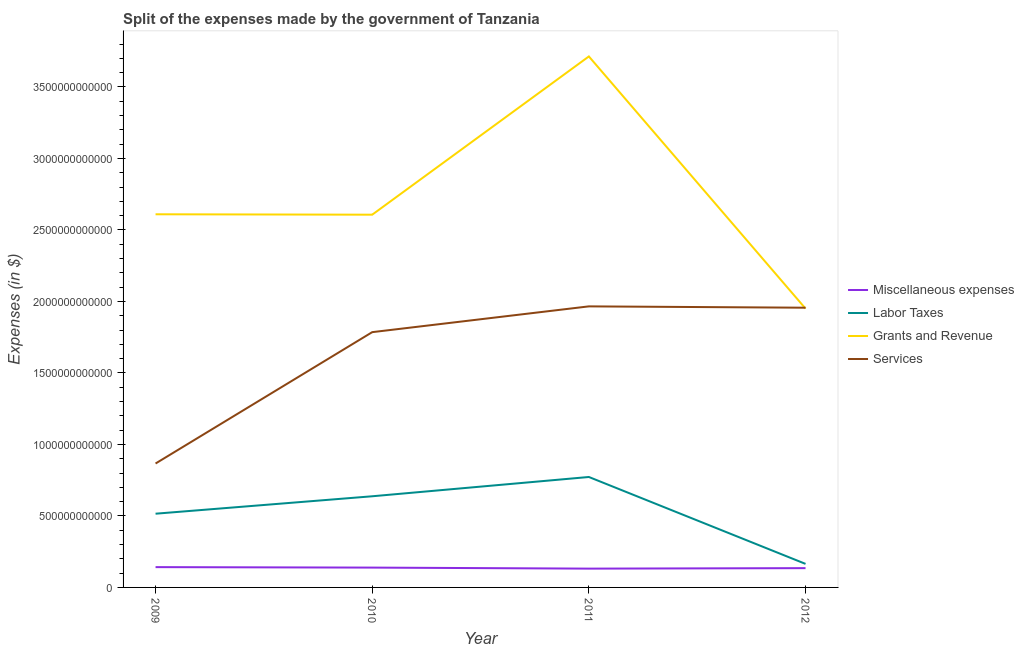How many different coloured lines are there?
Your answer should be very brief. 4. Is the number of lines equal to the number of legend labels?
Make the answer very short. Yes. What is the amount spent on services in 2010?
Give a very brief answer. 1.79e+12. Across all years, what is the maximum amount spent on miscellaneous expenses?
Make the answer very short. 1.42e+11. Across all years, what is the minimum amount spent on miscellaneous expenses?
Offer a very short reply. 1.31e+11. In which year was the amount spent on services maximum?
Provide a short and direct response. 2011. What is the total amount spent on grants and revenue in the graph?
Ensure brevity in your answer.  1.09e+13. What is the difference between the amount spent on labor taxes in 2009 and that in 2010?
Your response must be concise. -1.22e+11. What is the difference between the amount spent on grants and revenue in 2011 and the amount spent on services in 2010?
Offer a terse response. 1.93e+12. What is the average amount spent on services per year?
Provide a succinct answer. 1.64e+12. In the year 2012, what is the difference between the amount spent on grants and revenue and amount spent on labor taxes?
Provide a succinct answer. 1.79e+12. What is the ratio of the amount spent on services in 2009 to that in 2012?
Provide a short and direct response. 0.44. Is the difference between the amount spent on services in 2009 and 2011 greater than the difference between the amount spent on labor taxes in 2009 and 2011?
Your answer should be compact. No. What is the difference between the highest and the second highest amount spent on miscellaneous expenses?
Give a very brief answer. 3.24e+09. What is the difference between the highest and the lowest amount spent on grants and revenue?
Your response must be concise. 1.76e+12. In how many years, is the amount spent on services greater than the average amount spent on services taken over all years?
Your response must be concise. 3. Is it the case that in every year, the sum of the amount spent on services and amount spent on labor taxes is greater than the sum of amount spent on grants and revenue and amount spent on miscellaneous expenses?
Your answer should be very brief. Yes. Is the amount spent on miscellaneous expenses strictly greater than the amount spent on labor taxes over the years?
Ensure brevity in your answer.  No. How many lines are there?
Give a very brief answer. 4. How many years are there in the graph?
Provide a succinct answer. 4. What is the difference between two consecutive major ticks on the Y-axis?
Provide a succinct answer. 5.00e+11. Are the values on the major ticks of Y-axis written in scientific E-notation?
Your response must be concise. No. Does the graph contain any zero values?
Provide a succinct answer. No. Does the graph contain grids?
Offer a terse response. No. Where does the legend appear in the graph?
Ensure brevity in your answer.  Center right. How are the legend labels stacked?
Offer a terse response. Vertical. What is the title of the graph?
Ensure brevity in your answer.  Split of the expenses made by the government of Tanzania. What is the label or title of the Y-axis?
Your response must be concise. Expenses (in $). What is the Expenses (in $) of Miscellaneous expenses in 2009?
Give a very brief answer. 1.42e+11. What is the Expenses (in $) in Labor Taxes in 2009?
Your answer should be very brief. 5.16e+11. What is the Expenses (in $) in Grants and Revenue in 2009?
Offer a very short reply. 2.61e+12. What is the Expenses (in $) of Services in 2009?
Keep it short and to the point. 8.67e+11. What is the Expenses (in $) of Miscellaneous expenses in 2010?
Your answer should be compact. 1.39e+11. What is the Expenses (in $) in Labor Taxes in 2010?
Give a very brief answer. 6.38e+11. What is the Expenses (in $) in Grants and Revenue in 2010?
Ensure brevity in your answer.  2.61e+12. What is the Expenses (in $) in Services in 2010?
Your answer should be very brief. 1.79e+12. What is the Expenses (in $) in Miscellaneous expenses in 2011?
Offer a very short reply. 1.31e+11. What is the Expenses (in $) in Labor Taxes in 2011?
Your answer should be very brief. 7.72e+11. What is the Expenses (in $) of Grants and Revenue in 2011?
Your answer should be very brief. 3.71e+12. What is the Expenses (in $) in Services in 2011?
Offer a terse response. 1.97e+12. What is the Expenses (in $) in Miscellaneous expenses in 2012?
Offer a very short reply. 1.35e+11. What is the Expenses (in $) of Labor Taxes in 2012?
Keep it short and to the point. 1.65e+11. What is the Expenses (in $) of Grants and Revenue in 2012?
Your answer should be very brief. 1.95e+12. What is the Expenses (in $) in Services in 2012?
Keep it short and to the point. 1.96e+12. Across all years, what is the maximum Expenses (in $) in Miscellaneous expenses?
Give a very brief answer. 1.42e+11. Across all years, what is the maximum Expenses (in $) in Labor Taxes?
Keep it short and to the point. 7.72e+11. Across all years, what is the maximum Expenses (in $) of Grants and Revenue?
Provide a short and direct response. 3.71e+12. Across all years, what is the maximum Expenses (in $) of Services?
Your answer should be compact. 1.97e+12. Across all years, what is the minimum Expenses (in $) of Miscellaneous expenses?
Your response must be concise. 1.31e+11. Across all years, what is the minimum Expenses (in $) of Labor Taxes?
Offer a very short reply. 1.65e+11. Across all years, what is the minimum Expenses (in $) of Grants and Revenue?
Provide a succinct answer. 1.95e+12. Across all years, what is the minimum Expenses (in $) in Services?
Provide a short and direct response. 8.67e+11. What is the total Expenses (in $) of Miscellaneous expenses in the graph?
Your answer should be compact. 5.47e+11. What is the total Expenses (in $) of Labor Taxes in the graph?
Ensure brevity in your answer.  2.09e+12. What is the total Expenses (in $) in Grants and Revenue in the graph?
Offer a very short reply. 1.09e+13. What is the total Expenses (in $) of Services in the graph?
Give a very brief answer. 6.57e+12. What is the difference between the Expenses (in $) of Miscellaneous expenses in 2009 and that in 2010?
Provide a short and direct response. 3.24e+09. What is the difference between the Expenses (in $) of Labor Taxes in 2009 and that in 2010?
Your answer should be very brief. -1.22e+11. What is the difference between the Expenses (in $) in Grants and Revenue in 2009 and that in 2010?
Ensure brevity in your answer.  2.83e+09. What is the difference between the Expenses (in $) in Services in 2009 and that in 2010?
Offer a very short reply. -9.19e+11. What is the difference between the Expenses (in $) of Miscellaneous expenses in 2009 and that in 2011?
Ensure brevity in your answer.  1.05e+1. What is the difference between the Expenses (in $) of Labor Taxes in 2009 and that in 2011?
Your answer should be compact. -2.57e+11. What is the difference between the Expenses (in $) of Grants and Revenue in 2009 and that in 2011?
Keep it short and to the point. -1.10e+12. What is the difference between the Expenses (in $) in Services in 2009 and that in 2011?
Offer a terse response. -1.10e+12. What is the difference between the Expenses (in $) of Miscellaneous expenses in 2009 and that in 2012?
Provide a succinct answer. 7.09e+09. What is the difference between the Expenses (in $) in Labor Taxes in 2009 and that in 2012?
Provide a short and direct response. 3.51e+11. What is the difference between the Expenses (in $) in Grants and Revenue in 2009 and that in 2012?
Provide a succinct answer. 6.60e+11. What is the difference between the Expenses (in $) of Services in 2009 and that in 2012?
Your answer should be very brief. -1.09e+12. What is the difference between the Expenses (in $) of Miscellaneous expenses in 2010 and that in 2011?
Make the answer very short. 7.25e+09. What is the difference between the Expenses (in $) in Labor Taxes in 2010 and that in 2011?
Your answer should be compact. -1.35e+11. What is the difference between the Expenses (in $) of Grants and Revenue in 2010 and that in 2011?
Offer a terse response. -1.11e+12. What is the difference between the Expenses (in $) of Services in 2010 and that in 2011?
Your answer should be compact. -1.80e+11. What is the difference between the Expenses (in $) of Miscellaneous expenses in 2010 and that in 2012?
Your answer should be compact. 3.86e+09. What is the difference between the Expenses (in $) of Labor Taxes in 2010 and that in 2012?
Offer a terse response. 4.73e+11. What is the difference between the Expenses (in $) in Grants and Revenue in 2010 and that in 2012?
Keep it short and to the point. 6.57e+11. What is the difference between the Expenses (in $) in Services in 2010 and that in 2012?
Your answer should be very brief. -1.71e+11. What is the difference between the Expenses (in $) in Miscellaneous expenses in 2011 and that in 2012?
Offer a terse response. -3.39e+09. What is the difference between the Expenses (in $) in Labor Taxes in 2011 and that in 2012?
Give a very brief answer. 6.08e+11. What is the difference between the Expenses (in $) in Grants and Revenue in 2011 and that in 2012?
Offer a very short reply. 1.76e+12. What is the difference between the Expenses (in $) of Services in 2011 and that in 2012?
Give a very brief answer. 9.30e+09. What is the difference between the Expenses (in $) in Miscellaneous expenses in 2009 and the Expenses (in $) in Labor Taxes in 2010?
Offer a terse response. -4.96e+11. What is the difference between the Expenses (in $) of Miscellaneous expenses in 2009 and the Expenses (in $) of Grants and Revenue in 2010?
Your answer should be very brief. -2.46e+12. What is the difference between the Expenses (in $) of Miscellaneous expenses in 2009 and the Expenses (in $) of Services in 2010?
Give a very brief answer. -1.64e+12. What is the difference between the Expenses (in $) in Labor Taxes in 2009 and the Expenses (in $) in Grants and Revenue in 2010?
Your answer should be compact. -2.09e+12. What is the difference between the Expenses (in $) in Labor Taxes in 2009 and the Expenses (in $) in Services in 2010?
Your response must be concise. -1.27e+12. What is the difference between the Expenses (in $) of Grants and Revenue in 2009 and the Expenses (in $) of Services in 2010?
Provide a short and direct response. 8.24e+11. What is the difference between the Expenses (in $) in Miscellaneous expenses in 2009 and the Expenses (in $) in Labor Taxes in 2011?
Your answer should be very brief. -6.30e+11. What is the difference between the Expenses (in $) in Miscellaneous expenses in 2009 and the Expenses (in $) in Grants and Revenue in 2011?
Your answer should be very brief. -3.57e+12. What is the difference between the Expenses (in $) in Miscellaneous expenses in 2009 and the Expenses (in $) in Services in 2011?
Make the answer very short. -1.82e+12. What is the difference between the Expenses (in $) of Labor Taxes in 2009 and the Expenses (in $) of Grants and Revenue in 2011?
Make the answer very short. -3.20e+12. What is the difference between the Expenses (in $) of Labor Taxes in 2009 and the Expenses (in $) of Services in 2011?
Provide a short and direct response. -1.45e+12. What is the difference between the Expenses (in $) in Grants and Revenue in 2009 and the Expenses (in $) in Services in 2011?
Keep it short and to the point. 6.44e+11. What is the difference between the Expenses (in $) of Miscellaneous expenses in 2009 and the Expenses (in $) of Labor Taxes in 2012?
Your answer should be very brief. -2.27e+1. What is the difference between the Expenses (in $) of Miscellaneous expenses in 2009 and the Expenses (in $) of Grants and Revenue in 2012?
Keep it short and to the point. -1.81e+12. What is the difference between the Expenses (in $) in Miscellaneous expenses in 2009 and the Expenses (in $) in Services in 2012?
Provide a succinct answer. -1.81e+12. What is the difference between the Expenses (in $) in Labor Taxes in 2009 and the Expenses (in $) in Grants and Revenue in 2012?
Give a very brief answer. -1.43e+12. What is the difference between the Expenses (in $) of Labor Taxes in 2009 and the Expenses (in $) of Services in 2012?
Offer a very short reply. -1.44e+12. What is the difference between the Expenses (in $) in Grants and Revenue in 2009 and the Expenses (in $) in Services in 2012?
Give a very brief answer. 6.53e+11. What is the difference between the Expenses (in $) in Miscellaneous expenses in 2010 and the Expenses (in $) in Labor Taxes in 2011?
Ensure brevity in your answer.  -6.34e+11. What is the difference between the Expenses (in $) of Miscellaneous expenses in 2010 and the Expenses (in $) of Grants and Revenue in 2011?
Keep it short and to the point. -3.57e+12. What is the difference between the Expenses (in $) of Miscellaneous expenses in 2010 and the Expenses (in $) of Services in 2011?
Make the answer very short. -1.83e+12. What is the difference between the Expenses (in $) in Labor Taxes in 2010 and the Expenses (in $) in Grants and Revenue in 2011?
Your response must be concise. -3.08e+12. What is the difference between the Expenses (in $) in Labor Taxes in 2010 and the Expenses (in $) in Services in 2011?
Offer a terse response. -1.33e+12. What is the difference between the Expenses (in $) of Grants and Revenue in 2010 and the Expenses (in $) of Services in 2011?
Provide a succinct answer. 6.41e+11. What is the difference between the Expenses (in $) in Miscellaneous expenses in 2010 and the Expenses (in $) in Labor Taxes in 2012?
Keep it short and to the point. -2.59e+1. What is the difference between the Expenses (in $) in Miscellaneous expenses in 2010 and the Expenses (in $) in Grants and Revenue in 2012?
Provide a short and direct response. -1.81e+12. What is the difference between the Expenses (in $) of Miscellaneous expenses in 2010 and the Expenses (in $) of Services in 2012?
Your answer should be compact. -1.82e+12. What is the difference between the Expenses (in $) in Labor Taxes in 2010 and the Expenses (in $) in Grants and Revenue in 2012?
Offer a very short reply. -1.31e+12. What is the difference between the Expenses (in $) of Labor Taxes in 2010 and the Expenses (in $) of Services in 2012?
Your answer should be very brief. -1.32e+12. What is the difference between the Expenses (in $) of Grants and Revenue in 2010 and the Expenses (in $) of Services in 2012?
Make the answer very short. 6.51e+11. What is the difference between the Expenses (in $) of Miscellaneous expenses in 2011 and the Expenses (in $) of Labor Taxes in 2012?
Your response must be concise. -3.32e+1. What is the difference between the Expenses (in $) in Miscellaneous expenses in 2011 and the Expenses (in $) in Grants and Revenue in 2012?
Ensure brevity in your answer.  -1.82e+12. What is the difference between the Expenses (in $) of Miscellaneous expenses in 2011 and the Expenses (in $) of Services in 2012?
Offer a terse response. -1.82e+12. What is the difference between the Expenses (in $) in Labor Taxes in 2011 and the Expenses (in $) in Grants and Revenue in 2012?
Provide a succinct answer. -1.18e+12. What is the difference between the Expenses (in $) of Labor Taxes in 2011 and the Expenses (in $) of Services in 2012?
Ensure brevity in your answer.  -1.18e+12. What is the difference between the Expenses (in $) in Grants and Revenue in 2011 and the Expenses (in $) in Services in 2012?
Give a very brief answer. 1.76e+12. What is the average Expenses (in $) of Miscellaneous expenses per year?
Provide a succinct answer. 1.37e+11. What is the average Expenses (in $) in Labor Taxes per year?
Make the answer very short. 5.23e+11. What is the average Expenses (in $) in Grants and Revenue per year?
Keep it short and to the point. 2.72e+12. What is the average Expenses (in $) of Services per year?
Offer a very short reply. 1.64e+12. In the year 2009, what is the difference between the Expenses (in $) in Miscellaneous expenses and Expenses (in $) in Labor Taxes?
Make the answer very short. -3.74e+11. In the year 2009, what is the difference between the Expenses (in $) in Miscellaneous expenses and Expenses (in $) in Grants and Revenue?
Make the answer very short. -2.47e+12. In the year 2009, what is the difference between the Expenses (in $) of Miscellaneous expenses and Expenses (in $) of Services?
Your answer should be very brief. -7.25e+11. In the year 2009, what is the difference between the Expenses (in $) in Labor Taxes and Expenses (in $) in Grants and Revenue?
Make the answer very short. -2.09e+12. In the year 2009, what is the difference between the Expenses (in $) of Labor Taxes and Expenses (in $) of Services?
Offer a terse response. -3.51e+11. In the year 2009, what is the difference between the Expenses (in $) of Grants and Revenue and Expenses (in $) of Services?
Provide a short and direct response. 1.74e+12. In the year 2010, what is the difference between the Expenses (in $) of Miscellaneous expenses and Expenses (in $) of Labor Taxes?
Ensure brevity in your answer.  -4.99e+11. In the year 2010, what is the difference between the Expenses (in $) in Miscellaneous expenses and Expenses (in $) in Grants and Revenue?
Provide a succinct answer. -2.47e+12. In the year 2010, what is the difference between the Expenses (in $) in Miscellaneous expenses and Expenses (in $) in Services?
Provide a short and direct response. -1.65e+12. In the year 2010, what is the difference between the Expenses (in $) of Labor Taxes and Expenses (in $) of Grants and Revenue?
Your answer should be very brief. -1.97e+12. In the year 2010, what is the difference between the Expenses (in $) in Labor Taxes and Expenses (in $) in Services?
Your response must be concise. -1.15e+12. In the year 2010, what is the difference between the Expenses (in $) in Grants and Revenue and Expenses (in $) in Services?
Offer a very short reply. 8.22e+11. In the year 2011, what is the difference between the Expenses (in $) of Miscellaneous expenses and Expenses (in $) of Labor Taxes?
Ensure brevity in your answer.  -6.41e+11. In the year 2011, what is the difference between the Expenses (in $) in Miscellaneous expenses and Expenses (in $) in Grants and Revenue?
Provide a short and direct response. -3.58e+12. In the year 2011, what is the difference between the Expenses (in $) in Miscellaneous expenses and Expenses (in $) in Services?
Your answer should be very brief. -1.83e+12. In the year 2011, what is the difference between the Expenses (in $) in Labor Taxes and Expenses (in $) in Grants and Revenue?
Offer a terse response. -2.94e+12. In the year 2011, what is the difference between the Expenses (in $) of Labor Taxes and Expenses (in $) of Services?
Provide a succinct answer. -1.19e+12. In the year 2011, what is the difference between the Expenses (in $) of Grants and Revenue and Expenses (in $) of Services?
Your answer should be compact. 1.75e+12. In the year 2012, what is the difference between the Expenses (in $) in Miscellaneous expenses and Expenses (in $) in Labor Taxes?
Your answer should be very brief. -2.98e+1. In the year 2012, what is the difference between the Expenses (in $) of Miscellaneous expenses and Expenses (in $) of Grants and Revenue?
Make the answer very short. -1.82e+12. In the year 2012, what is the difference between the Expenses (in $) in Miscellaneous expenses and Expenses (in $) in Services?
Give a very brief answer. -1.82e+12. In the year 2012, what is the difference between the Expenses (in $) of Labor Taxes and Expenses (in $) of Grants and Revenue?
Offer a terse response. -1.79e+12. In the year 2012, what is the difference between the Expenses (in $) of Labor Taxes and Expenses (in $) of Services?
Your response must be concise. -1.79e+12. In the year 2012, what is the difference between the Expenses (in $) of Grants and Revenue and Expenses (in $) of Services?
Provide a succinct answer. -6.18e+09. What is the ratio of the Expenses (in $) in Miscellaneous expenses in 2009 to that in 2010?
Offer a terse response. 1.02. What is the ratio of the Expenses (in $) in Labor Taxes in 2009 to that in 2010?
Provide a short and direct response. 0.81. What is the ratio of the Expenses (in $) in Grants and Revenue in 2009 to that in 2010?
Offer a terse response. 1. What is the ratio of the Expenses (in $) in Services in 2009 to that in 2010?
Your answer should be very brief. 0.49. What is the ratio of the Expenses (in $) of Miscellaneous expenses in 2009 to that in 2011?
Offer a terse response. 1.08. What is the ratio of the Expenses (in $) in Labor Taxes in 2009 to that in 2011?
Your answer should be very brief. 0.67. What is the ratio of the Expenses (in $) in Grants and Revenue in 2009 to that in 2011?
Offer a terse response. 0.7. What is the ratio of the Expenses (in $) of Services in 2009 to that in 2011?
Ensure brevity in your answer.  0.44. What is the ratio of the Expenses (in $) in Miscellaneous expenses in 2009 to that in 2012?
Your response must be concise. 1.05. What is the ratio of the Expenses (in $) in Labor Taxes in 2009 to that in 2012?
Offer a very short reply. 3.13. What is the ratio of the Expenses (in $) in Grants and Revenue in 2009 to that in 2012?
Give a very brief answer. 1.34. What is the ratio of the Expenses (in $) in Services in 2009 to that in 2012?
Your answer should be very brief. 0.44. What is the ratio of the Expenses (in $) in Miscellaneous expenses in 2010 to that in 2011?
Give a very brief answer. 1.06. What is the ratio of the Expenses (in $) of Labor Taxes in 2010 to that in 2011?
Provide a short and direct response. 0.83. What is the ratio of the Expenses (in $) of Grants and Revenue in 2010 to that in 2011?
Ensure brevity in your answer.  0.7. What is the ratio of the Expenses (in $) in Services in 2010 to that in 2011?
Provide a short and direct response. 0.91. What is the ratio of the Expenses (in $) in Miscellaneous expenses in 2010 to that in 2012?
Provide a succinct answer. 1.03. What is the ratio of the Expenses (in $) in Labor Taxes in 2010 to that in 2012?
Offer a terse response. 3.87. What is the ratio of the Expenses (in $) in Grants and Revenue in 2010 to that in 2012?
Provide a succinct answer. 1.34. What is the ratio of the Expenses (in $) of Services in 2010 to that in 2012?
Your answer should be very brief. 0.91. What is the ratio of the Expenses (in $) in Miscellaneous expenses in 2011 to that in 2012?
Ensure brevity in your answer.  0.97. What is the ratio of the Expenses (in $) of Labor Taxes in 2011 to that in 2012?
Your response must be concise. 4.69. What is the ratio of the Expenses (in $) of Grants and Revenue in 2011 to that in 2012?
Give a very brief answer. 1.9. What is the difference between the highest and the second highest Expenses (in $) in Miscellaneous expenses?
Keep it short and to the point. 3.24e+09. What is the difference between the highest and the second highest Expenses (in $) of Labor Taxes?
Ensure brevity in your answer.  1.35e+11. What is the difference between the highest and the second highest Expenses (in $) of Grants and Revenue?
Give a very brief answer. 1.10e+12. What is the difference between the highest and the second highest Expenses (in $) in Services?
Your answer should be compact. 9.30e+09. What is the difference between the highest and the lowest Expenses (in $) of Miscellaneous expenses?
Give a very brief answer. 1.05e+1. What is the difference between the highest and the lowest Expenses (in $) in Labor Taxes?
Your answer should be very brief. 6.08e+11. What is the difference between the highest and the lowest Expenses (in $) of Grants and Revenue?
Offer a very short reply. 1.76e+12. What is the difference between the highest and the lowest Expenses (in $) of Services?
Provide a succinct answer. 1.10e+12. 